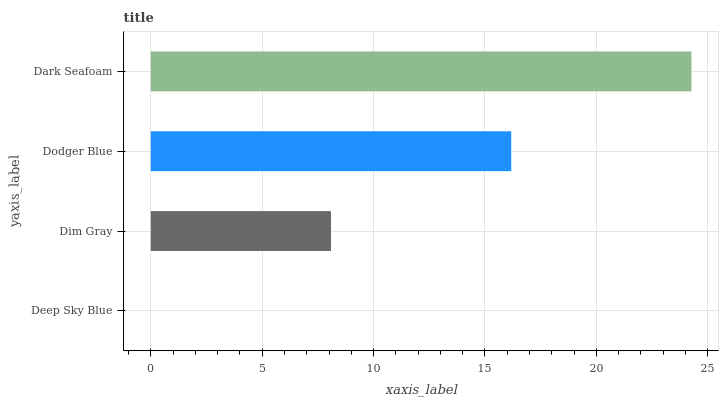Is Deep Sky Blue the minimum?
Answer yes or no. Yes. Is Dark Seafoam the maximum?
Answer yes or no. Yes. Is Dim Gray the minimum?
Answer yes or no. No. Is Dim Gray the maximum?
Answer yes or no. No. Is Dim Gray greater than Deep Sky Blue?
Answer yes or no. Yes. Is Deep Sky Blue less than Dim Gray?
Answer yes or no. Yes. Is Deep Sky Blue greater than Dim Gray?
Answer yes or no. No. Is Dim Gray less than Deep Sky Blue?
Answer yes or no. No. Is Dodger Blue the high median?
Answer yes or no. Yes. Is Dim Gray the low median?
Answer yes or no. Yes. Is Dim Gray the high median?
Answer yes or no. No. Is Dodger Blue the low median?
Answer yes or no. No. 